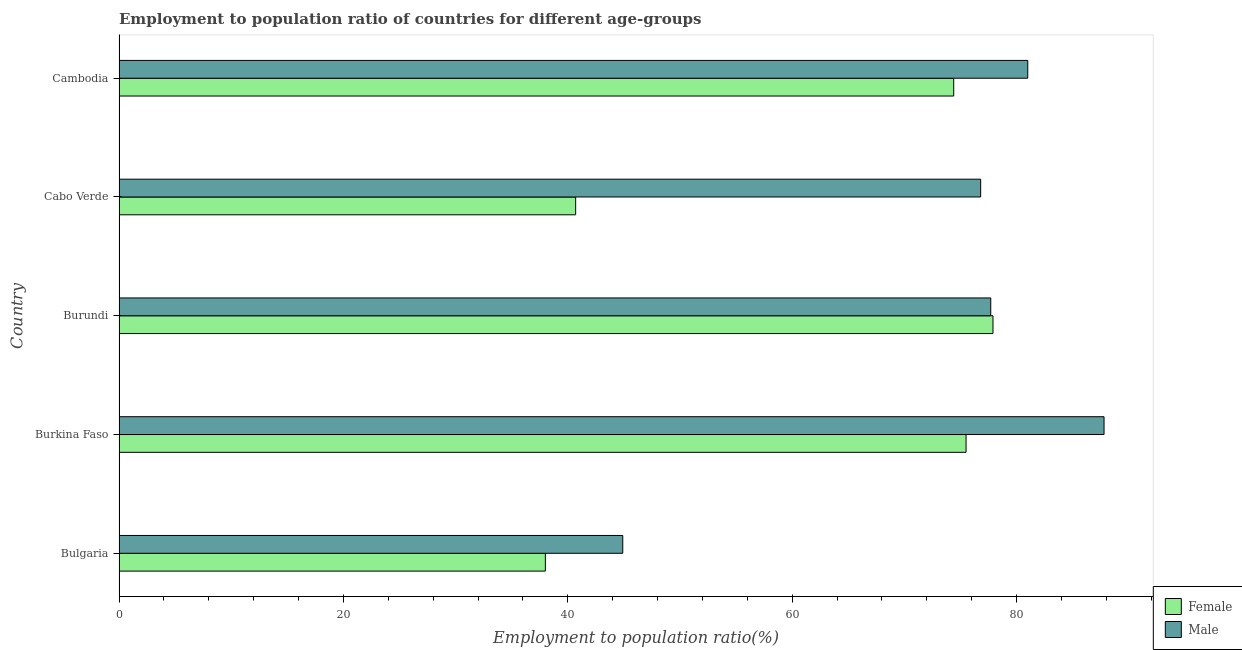How many different coloured bars are there?
Offer a terse response. 2. Are the number of bars per tick equal to the number of legend labels?
Provide a short and direct response. Yes. What is the label of the 1st group of bars from the top?
Your answer should be very brief. Cambodia. What is the employment to population ratio(male) in Cambodia?
Keep it short and to the point. 81. Across all countries, what is the maximum employment to population ratio(female)?
Provide a short and direct response. 77.9. In which country was the employment to population ratio(female) maximum?
Ensure brevity in your answer.  Burundi. In which country was the employment to population ratio(female) minimum?
Offer a very short reply. Bulgaria. What is the total employment to population ratio(female) in the graph?
Your response must be concise. 306.5. What is the difference between the employment to population ratio(male) in Bulgaria and the employment to population ratio(female) in Cambodia?
Offer a terse response. -29.5. What is the average employment to population ratio(male) per country?
Keep it short and to the point. 73.64. What is the difference between the employment to population ratio(female) and employment to population ratio(male) in Cambodia?
Provide a short and direct response. -6.6. In how many countries, is the employment to population ratio(male) greater than 88 %?
Your response must be concise. 0. What is the ratio of the employment to population ratio(female) in Bulgaria to that in Cambodia?
Keep it short and to the point. 0.51. Is the difference between the employment to population ratio(female) in Burundi and Cambodia greater than the difference between the employment to population ratio(male) in Burundi and Cambodia?
Keep it short and to the point. Yes. What is the difference between the highest and the lowest employment to population ratio(male)?
Provide a short and direct response. 42.9. Is the sum of the employment to population ratio(female) in Cabo Verde and Cambodia greater than the maximum employment to population ratio(male) across all countries?
Provide a short and direct response. Yes. How many bars are there?
Provide a succinct answer. 10. What is the difference between two consecutive major ticks on the X-axis?
Ensure brevity in your answer.  20. Does the graph contain grids?
Offer a very short reply. No. Where does the legend appear in the graph?
Ensure brevity in your answer.  Bottom right. What is the title of the graph?
Give a very brief answer. Employment to population ratio of countries for different age-groups. Does "Drinking water services" appear as one of the legend labels in the graph?
Ensure brevity in your answer.  No. What is the label or title of the X-axis?
Your answer should be compact. Employment to population ratio(%). What is the Employment to population ratio(%) in Male in Bulgaria?
Offer a very short reply. 44.9. What is the Employment to population ratio(%) in Female in Burkina Faso?
Offer a terse response. 75.5. What is the Employment to population ratio(%) in Male in Burkina Faso?
Make the answer very short. 87.8. What is the Employment to population ratio(%) of Female in Burundi?
Your answer should be very brief. 77.9. What is the Employment to population ratio(%) of Male in Burundi?
Provide a short and direct response. 77.7. What is the Employment to population ratio(%) in Female in Cabo Verde?
Provide a succinct answer. 40.7. What is the Employment to population ratio(%) in Male in Cabo Verde?
Provide a short and direct response. 76.8. What is the Employment to population ratio(%) of Female in Cambodia?
Your response must be concise. 74.4. Across all countries, what is the maximum Employment to population ratio(%) in Female?
Your answer should be compact. 77.9. Across all countries, what is the maximum Employment to population ratio(%) in Male?
Offer a terse response. 87.8. Across all countries, what is the minimum Employment to population ratio(%) in Female?
Provide a succinct answer. 38. Across all countries, what is the minimum Employment to population ratio(%) in Male?
Offer a very short reply. 44.9. What is the total Employment to population ratio(%) of Female in the graph?
Your answer should be very brief. 306.5. What is the total Employment to population ratio(%) of Male in the graph?
Your answer should be very brief. 368.2. What is the difference between the Employment to population ratio(%) in Female in Bulgaria and that in Burkina Faso?
Offer a terse response. -37.5. What is the difference between the Employment to population ratio(%) in Male in Bulgaria and that in Burkina Faso?
Provide a short and direct response. -42.9. What is the difference between the Employment to population ratio(%) of Female in Bulgaria and that in Burundi?
Your answer should be very brief. -39.9. What is the difference between the Employment to population ratio(%) in Male in Bulgaria and that in Burundi?
Provide a short and direct response. -32.8. What is the difference between the Employment to population ratio(%) in Female in Bulgaria and that in Cabo Verde?
Provide a succinct answer. -2.7. What is the difference between the Employment to population ratio(%) in Male in Bulgaria and that in Cabo Verde?
Provide a short and direct response. -31.9. What is the difference between the Employment to population ratio(%) in Female in Bulgaria and that in Cambodia?
Offer a terse response. -36.4. What is the difference between the Employment to population ratio(%) in Male in Bulgaria and that in Cambodia?
Your answer should be very brief. -36.1. What is the difference between the Employment to population ratio(%) of Male in Burkina Faso and that in Burundi?
Give a very brief answer. 10.1. What is the difference between the Employment to population ratio(%) of Female in Burkina Faso and that in Cabo Verde?
Keep it short and to the point. 34.8. What is the difference between the Employment to population ratio(%) in Male in Burkina Faso and that in Cambodia?
Your answer should be compact. 6.8. What is the difference between the Employment to population ratio(%) in Female in Burundi and that in Cabo Verde?
Your answer should be compact. 37.2. What is the difference between the Employment to population ratio(%) in Male in Burundi and that in Cambodia?
Your answer should be compact. -3.3. What is the difference between the Employment to population ratio(%) in Female in Cabo Verde and that in Cambodia?
Your answer should be very brief. -33.7. What is the difference between the Employment to population ratio(%) of Male in Cabo Verde and that in Cambodia?
Your response must be concise. -4.2. What is the difference between the Employment to population ratio(%) of Female in Bulgaria and the Employment to population ratio(%) of Male in Burkina Faso?
Your answer should be very brief. -49.8. What is the difference between the Employment to population ratio(%) of Female in Bulgaria and the Employment to population ratio(%) of Male in Burundi?
Keep it short and to the point. -39.7. What is the difference between the Employment to population ratio(%) of Female in Bulgaria and the Employment to population ratio(%) of Male in Cabo Verde?
Provide a short and direct response. -38.8. What is the difference between the Employment to population ratio(%) in Female in Bulgaria and the Employment to population ratio(%) in Male in Cambodia?
Offer a terse response. -43. What is the difference between the Employment to population ratio(%) of Female in Burkina Faso and the Employment to population ratio(%) of Male in Burundi?
Offer a terse response. -2.2. What is the difference between the Employment to population ratio(%) of Female in Burkina Faso and the Employment to population ratio(%) of Male in Cambodia?
Provide a short and direct response. -5.5. What is the difference between the Employment to population ratio(%) of Female in Cabo Verde and the Employment to population ratio(%) of Male in Cambodia?
Provide a short and direct response. -40.3. What is the average Employment to population ratio(%) of Female per country?
Offer a very short reply. 61.3. What is the average Employment to population ratio(%) in Male per country?
Provide a short and direct response. 73.64. What is the difference between the Employment to population ratio(%) of Female and Employment to population ratio(%) of Male in Burkina Faso?
Offer a terse response. -12.3. What is the difference between the Employment to population ratio(%) of Female and Employment to population ratio(%) of Male in Cabo Verde?
Give a very brief answer. -36.1. What is the ratio of the Employment to population ratio(%) of Female in Bulgaria to that in Burkina Faso?
Your answer should be compact. 0.5. What is the ratio of the Employment to population ratio(%) of Male in Bulgaria to that in Burkina Faso?
Offer a terse response. 0.51. What is the ratio of the Employment to population ratio(%) in Female in Bulgaria to that in Burundi?
Ensure brevity in your answer.  0.49. What is the ratio of the Employment to population ratio(%) in Male in Bulgaria to that in Burundi?
Your answer should be very brief. 0.58. What is the ratio of the Employment to population ratio(%) of Female in Bulgaria to that in Cabo Verde?
Ensure brevity in your answer.  0.93. What is the ratio of the Employment to population ratio(%) of Male in Bulgaria to that in Cabo Verde?
Offer a terse response. 0.58. What is the ratio of the Employment to population ratio(%) in Female in Bulgaria to that in Cambodia?
Offer a very short reply. 0.51. What is the ratio of the Employment to population ratio(%) of Male in Bulgaria to that in Cambodia?
Your response must be concise. 0.55. What is the ratio of the Employment to population ratio(%) in Female in Burkina Faso to that in Burundi?
Your response must be concise. 0.97. What is the ratio of the Employment to population ratio(%) of Male in Burkina Faso to that in Burundi?
Your answer should be compact. 1.13. What is the ratio of the Employment to population ratio(%) in Female in Burkina Faso to that in Cabo Verde?
Your answer should be compact. 1.85. What is the ratio of the Employment to population ratio(%) of Male in Burkina Faso to that in Cabo Verde?
Give a very brief answer. 1.14. What is the ratio of the Employment to population ratio(%) of Female in Burkina Faso to that in Cambodia?
Provide a short and direct response. 1.01. What is the ratio of the Employment to population ratio(%) of Male in Burkina Faso to that in Cambodia?
Offer a terse response. 1.08. What is the ratio of the Employment to population ratio(%) of Female in Burundi to that in Cabo Verde?
Make the answer very short. 1.91. What is the ratio of the Employment to population ratio(%) in Male in Burundi to that in Cabo Verde?
Keep it short and to the point. 1.01. What is the ratio of the Employment to population ratio(%) of Female in Burundi to that in Cambodia?
Give a very brief answer. 1.05. What is the ratio of the Employment to population ratio(%) in Male in Burundi to that in Cambodia?
Offer a terse response. 0.96. What is the ratio of the Employment to population ratio(%) in Female in Cabo Verde to that in Cambodia?
Offer a very short reply. 0.55. What is the ratio of the Employment to population ratio(%) of Male in Cabo Verde to that in Cambodia?
Your response must be concise. 0.95. What is the difference between the highest and the second highest Employment to population ratio(%) of Female?
Provide a succinct answer. 2.4. What is the difference between the highest and the lowest Employment to population ratio(%) in Female?
Offer a very short reply. 39.9. What is the difference between the highest and the lowest Employment to population ratio(%) in Male?
Make the answer very short. 42.9. 